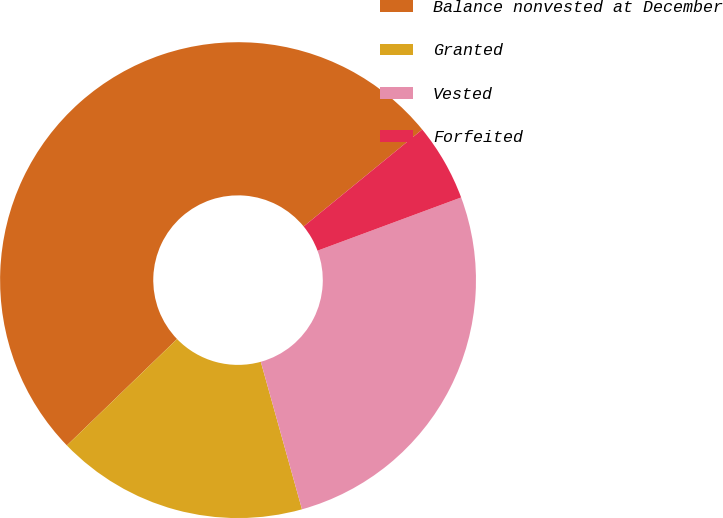Convert chart to OTSL. <chart><loc_0><loc_0><loc_500><loc_500><pie_chart><fcel>Balance nonvested at December<fcel>Granted<fcel>Vested<fcel>Forfeited<nl><fcel>51.32%<fcel>17.11%<fcel>26.32%<fcel>5.26%<nl></chart> 